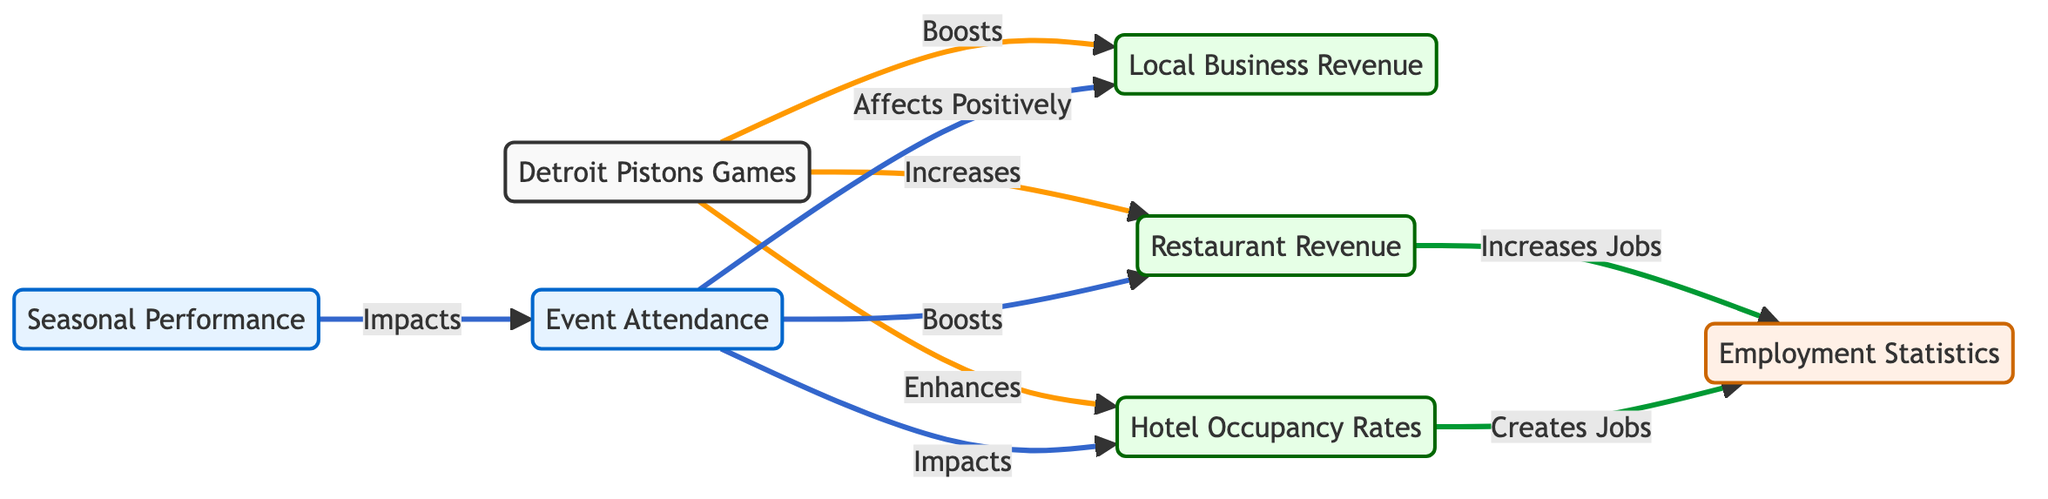What does the Detroit Pistons Games node boost? The diagram shows that the Detroit Pistons Games node has arrows pointing towards the Local Business Revenue node, indicating a boosting effect. This means that when the Pistons play games, it positively impacts the revenue of local businesses.
Answer: Local Business Revenue How many types of revenues are represented in the diagram? By examining the diagram, we can see three specific revenue types indicated by the nodes: Local Business Revenue, Restaurant Revenue, and Hotel Occupancy Rates. Thus, there are three types of revenues represented.
Answer: Three What is the relationship between event attendance and restaurant revenue? The diagram depicts an arrow originating from the Event Attendance node that points to the Restaurant Revenue node, indicating that event attendance has a positive impact on restaurant revenue. This shows a direct relationship between the two.
Answer: Affects Positively Which node is impacted by the seasonal performance? The arrows indicate that the Seasonal Performance node directly impacts the Event Attendance node. This suggests that the performance of the Pistons during the season influences how many attendees come to events.
Answer: Event Attendance How does restaurant revenue contribute to employment statistics? The diagram illustrates that there is a directional arrow from the Restaurant Revenue node to the Employment Statistics node, indicating that an increase in restaurant revenue leads to an increase in jobs. This means restaurant revenue directly contributes to employment statistics.
Answer: Increases Jobs What three nodes are enhanced by event attendance? The diagram shows that the Event Attendance node positively affects three nodes: Local Business Revenue, Restaurant Revenue, and Hotel Occupancy Rates. This illustrates the broad impact of event attendance on the economy.
Answer: Local Business Revenue, Restaurant Revenue, Hotel Occupancy Rates How many edges are there in the diagram? By counting the lines (edges) that connect the nodes, we can determine the number of edges. In this diagram, there are a total of 8 connections (edges) between the nodes.
Answer: Eight Which outcome is created as a result of hotel occupancy rates? According to the diagram, there is a connection from the Hotel Occupancy Rates node that leads to the Employment Statistics node. This implies that hotel occupancy rates create jobs as their occupancy increases.
Answer: Creates Jobs What category do the Detroit Pistons Games fall under? The node representing the Detroit Pistons Games is classified under the default category according to the diagram. This categorization indicates it does not have a specific focus on performance, revenue, or employment.
Answer: Default 